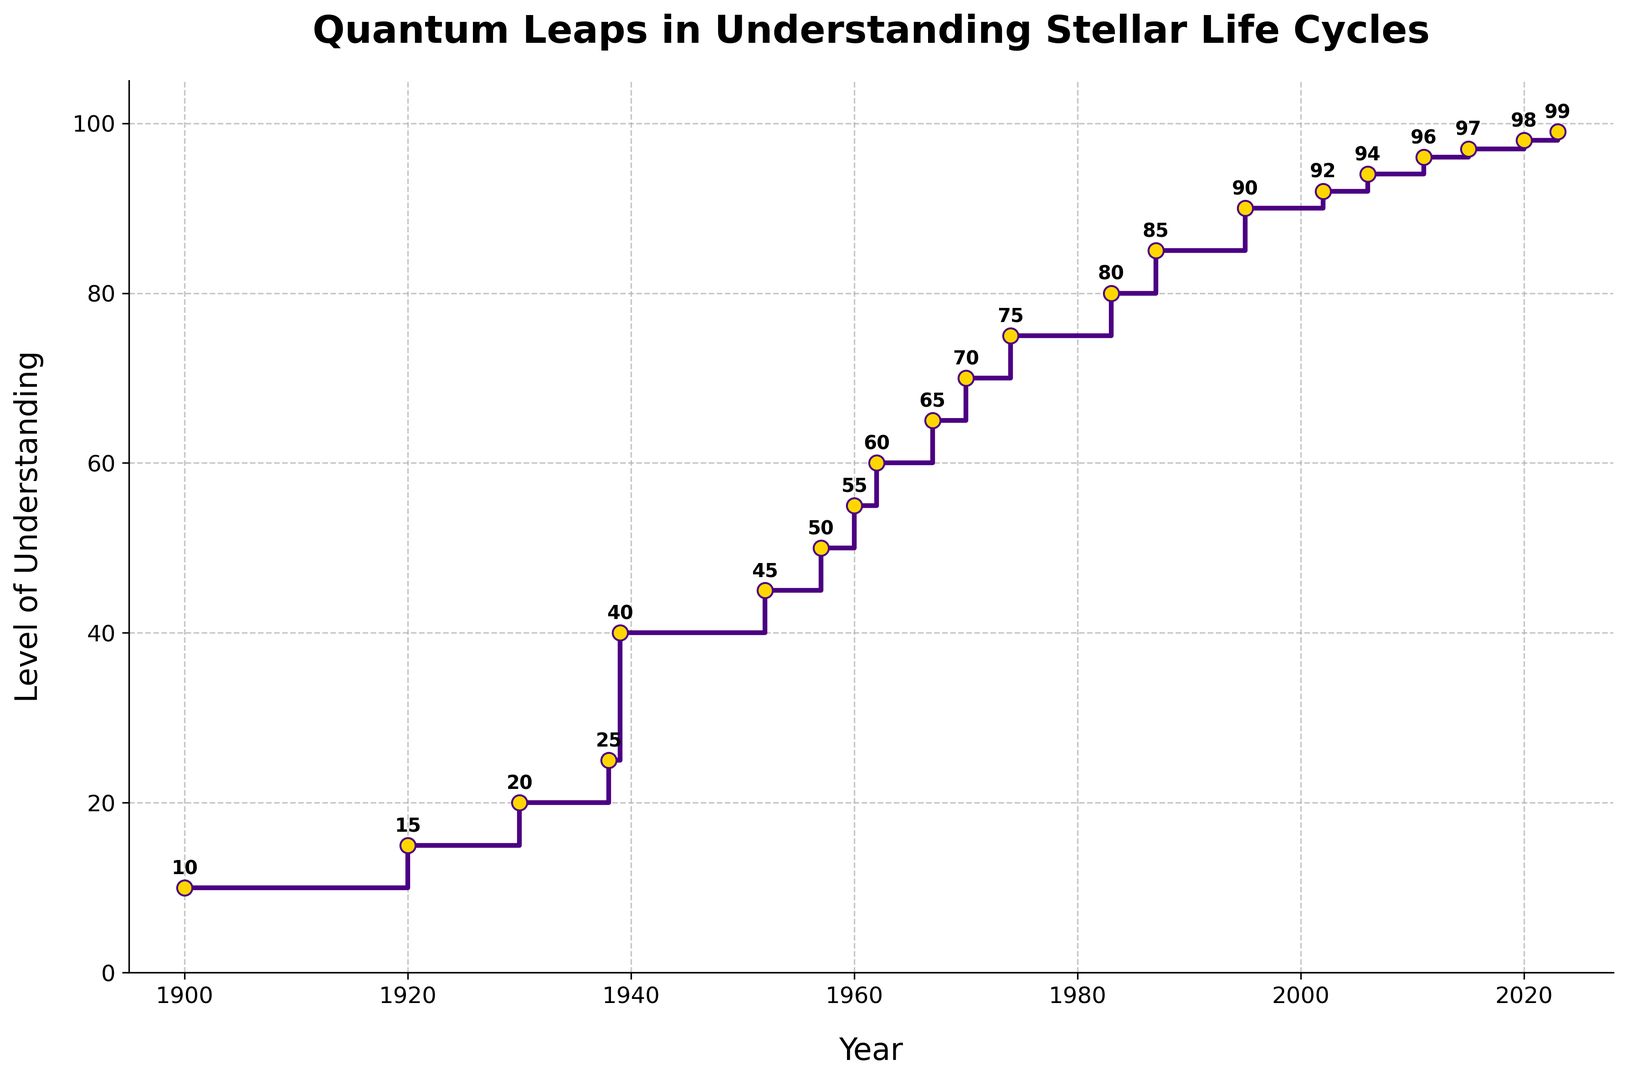What is the largest increase in the level of understanding within the shortest period? The step from 1938 to 1939 shows the largest increase in the level of understanding from 25 to 40, which is a 15-unit increase within one year.
Answer: 15 In which decade did the level of understanding see the first major jump? The first major jump is in the 1930s, where in 1938 the level was at 25 and jumped to 40 in 1939.
Answer: 1930s By how much did the level of understanding increase between 1900 and 1920? The level of understanding increased from 10 in 1900 to 15 in 1920, which is a 5-unit increase.
Answer: 5 How many years did it take to go from an understanding level of 10 to an understanding level of 50? It went from a level of 10 in 1900 to a level of 50 in 1957. So, it took 1957 - 1900 = 57 years.
Answer: 57 During which period does the plot show the steepest slope? The steepest slope is observed between 1938 and 1939, where the level of understanding increases by 15 in just one year.
Answer: 1938-1939 Which decade saw an increase from a level of 60 to 70? The increase from a level of 60 to 70 happened in the decade of the 1960s. Specifically, from 1962 to 1970.
Answer: 1960s What is the average level of understanding for the 2000s? The levels of understanding in the 2000s are 92 (2002), 94 (2006), and 96 (2011). The average is (92 + 94 + 96) / 3 = 282 / 3 = 94.
Answer: 94 By how much did the understanding level change between 1939 and 1952? The level of understanding was 40 in 1939 and 45 in 1952. The change is 45 - 40 = 5.
Answer: 5 What visual feature indicates the incremental steps in understanding? The stairs plot uses steps and markers to indicate changes in understanding levels, with each step occurring at a specified year.
Answer: steps and markers What is the smallest increment in understanding shown in the plot? The smallest increment is from 2015 to 2020, where the level of understanding goes from 97 to 98.
Answer: 1 